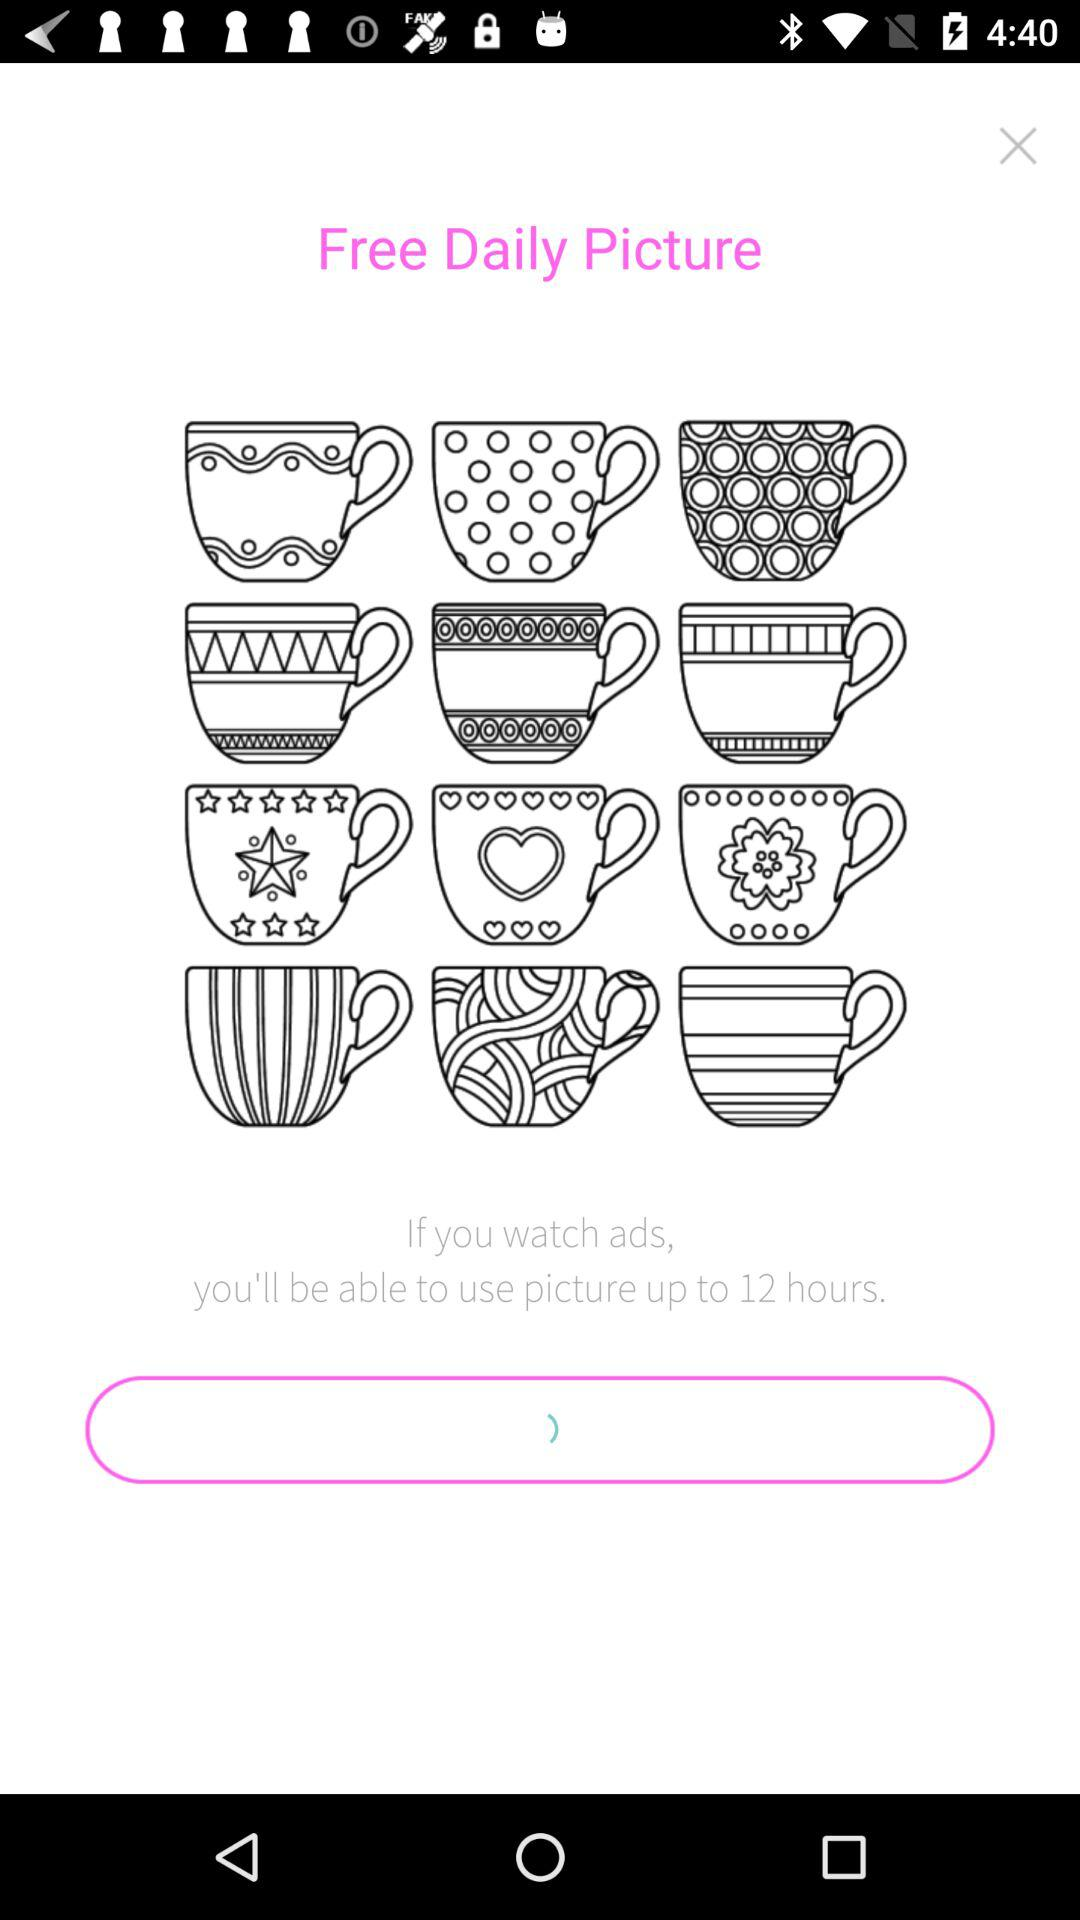For how long will we be able to use pictures? You will be able to use the picture for up to 12 hours. 